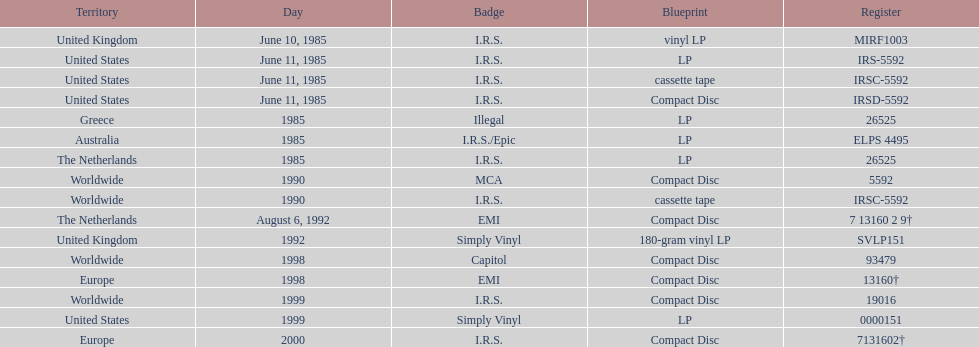In how many countries was the record released before the year 1990? 5. 